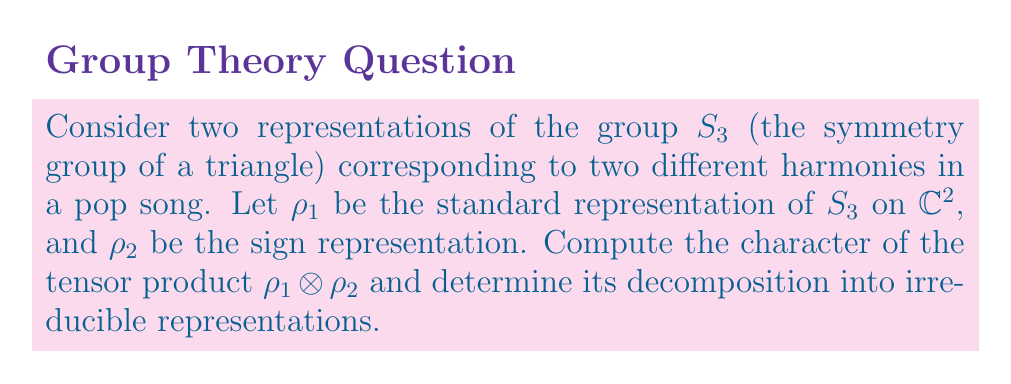Show me your answer to this math problem. 1) First, recall the character table for $S_3$:
   
   $$\begin{array}{c|ccc}
   S_3 & e & (12) & (123) \\
   \hline
   \chi_{\text{trivial}} & 1 & 1 & 1 \\
   \chi_{\text{sign}} & 1 & -1 & 1 \\
   \chi_{\text{standard}} & 2 & 0 & -1
   \end{array}$$

2) The character of $\rho_1$ (standard representation) is $\chi_1 = (2, 0, -1)$.

3) The character of $\rho_2$ (sign representation) is $\chi_2 = (1, -1, 1)$.

4) To compute the character of the tensor product, we multiply the character values pointwise:
   
   $\chi_{\rho_1 \otimes \rho_2} = (2 \cdot 1, 0 \cdot (-1), -1 \cdot 1) = (2, 0, -1)$

5) We observe that this is exactly the character of the standard representation.

6) Therefore, $\rho_1 \otimes \rho_2 \cong \rho_1$ (the standard representation).

This result can be interpreted musically as the combination of two harmonies (represented by $\rho_1$ and $\rho_2$) resulting in a new harmony that has the same structure as the original standard harmony ($\rho_1$).
Answer: $\rho_1 \otimes \rho_2 \cong \rho_1$ (standard representation) 